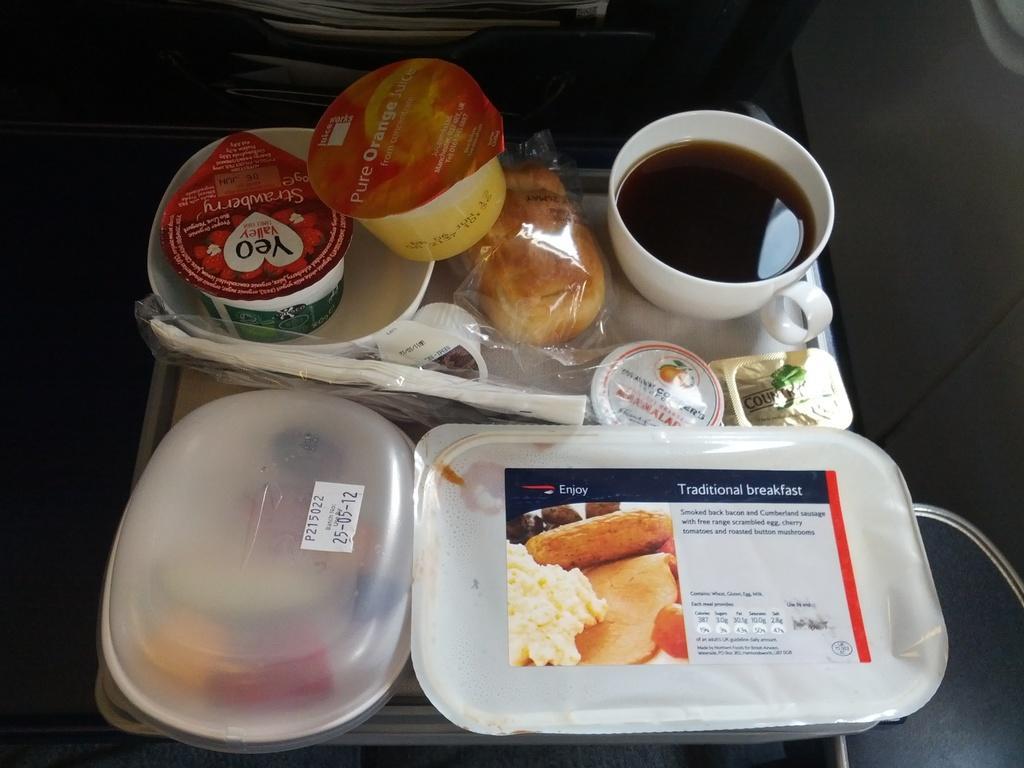Please provide a concise description of this image. In this image there are food items which are packed. 